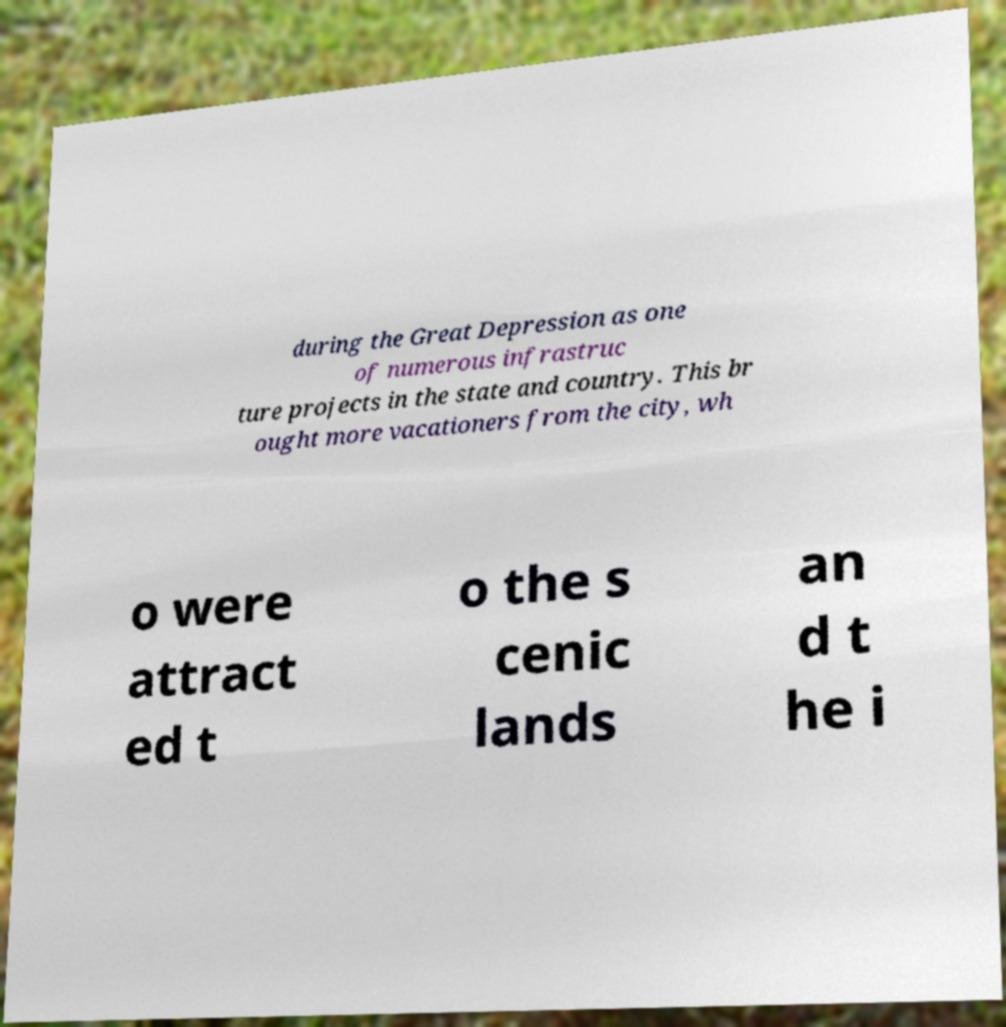Can you read and provide the text displayed in the image?This photo seems to have some interesting text. Can you extract and type it out for me? during the Great Depression as one of numerous infrastruc ture projects in the state and country. This br ought more vacationers from the city, wh o were attract ed t o the s cenic lands an d t he i 